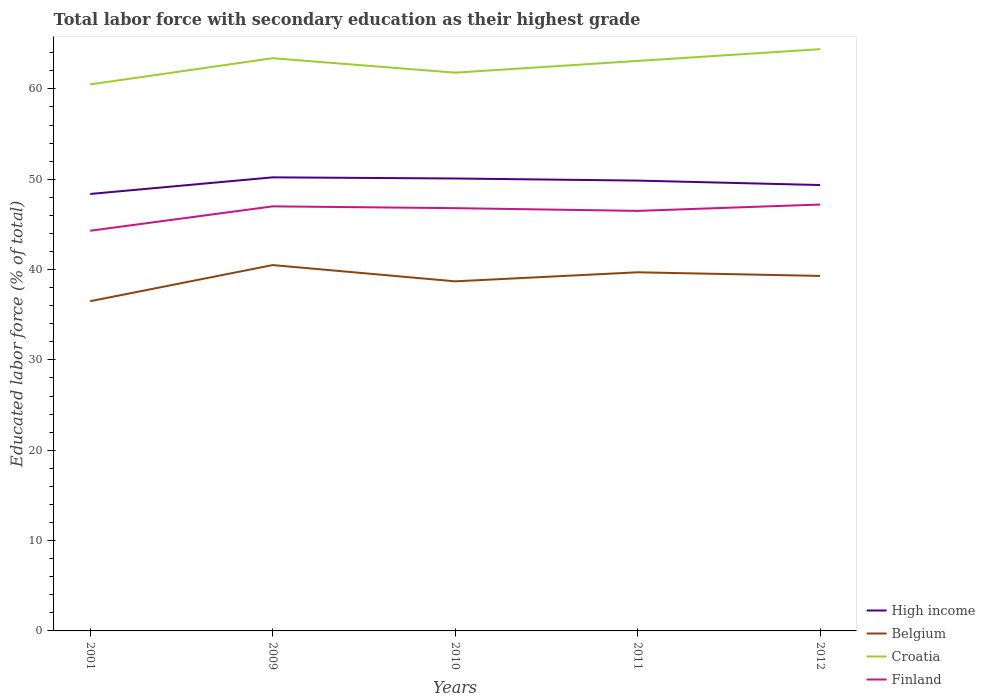Does the line corresponding to Croatia intersect with the line corresponding to High income?
Ensure brevity in your answer.  No. Across all years, what is the maximum percentage of total labor force with primary education in Finland?
Provide a short and direct response. 44.3. In which year was the percentage of total labor force with primary education in High income maximum?
Your answer should be compact. 2001. What is the total percentage of total labor force with primary education in Croatia in the graph?
Provide a succinct answer. 0.3. How many lines are there?
Offer a terse response. 4. How many years are there in the graph?
Keep it short and to the point. 5. What is the difference between two consecutive major ticks on the Y-axis?
Provide a succinct answer. 10. Does the graph contain grids?
Your answer should be very brief. No. How are the legend labels stacked?
Your response must be concise. Vertical. What is the title of the graph?
Provide a short and direct response. Total labor force with secondary education as their highest grade. What is the label or title of the Y-axis?
Make the answer very short. Educated labor force (% of total). What is the Educated labor force (% of total) in High income in 2001?
Offer a terse response. 48.37. What is the Educated labor force (% of total) of Belgium in 2001?
Give a very brief answer. 36.5. What is the Educated labor force (% of total) of Croatia in 2001?
Offer a very short reply. 60.5. What is the Educated labor force (% of total) of Finland in 2001?
Provide a short and direct response. 44.3. What is the Educated labor force (% of total) of High income in 2009?
Provide a succinct answer. 50.21. What is the Educated labor force (% of total) of Belgium in 2009?
Keep it short and to the point. 40.5. What is the Educated labor force (% of total) of Croatia in 2009?
Provide a short and direct response. 63.4. What is the Educated labor force (% of total) of High income in 2010?
Provide a succinct answer. 50.08. What is the Educated labor force (% of total) in Belgium in 2010?
Provide a succinct answer. 38.7. What is the Educated labor force (% of total) of Croatia in 2010?
Provide a short and direct response. 61.8. What is the Educated labor force (% of total) of Finland in 2010?
Give a very brief answer. 46.8. What is the Educated labor force (% of total) in High income in 2011?
Provide a succinct answer. 49.85. What is the Educated labor force (% of total) of Belgium in 2011?
Make the answer very short. 39.7. What is the Educated labor force (% of total) in Croatia in 2011?
Offer a terse response. 63.1. What is the Educated labor force (% of total) in Finland in 2011?
Your response must be concise. 46.5. What is the Educated labor force (% of total) in High income in 2012?
Keep it short and to the point. 49.36. What is the Educated labor force (% of total) of Belgium in 2012?
Ensure brevity in your answer.  39.3. What is the Educated labor force (% of total) in Croatia in 2012?
Your answer should be very brief. 64.4. What is the Educated labor force (% of total) of Finland in 2012?
Make the answer very short. 47.2. Across all years, what is the maximum Educated labor force (% of total) in High income?
Offer a terse response. 50.21. Across all years, what is the maximum Educated labor force (% of total) in Belgium?
Your answer should be very brief. 40.5. Across all years, what is the maximum Educated labor force (% of total) in Croatia?
Ensure brevity in your answer.  64.4. Across all years, what is the maximum Educated labor force (% of total) in Finland?
Your response must be concise. 47.2. Across all years, what is the minimum Educated labor force (% of total) in High income?
Provide a succinct answer. 48.37. Across all years, what is the minimum Educated labor force (% of total) in Belgium?
Your answer should be very brief. 36.5. Across all years, what is the minimum Educated labor force (% of total) of Croatia?
Give a very brief answer. 60.5. Across all years, what is the minimum Educated labor force (% of total) of Finland?
Offer a very short reply. 44.3. What is the total Educated labor force (% of total) in High income in the graph?
Your answer should be very brief. 247.88. What is the total Educated labor force (% of total) in Belgium in the graph?
Provide a short and direct response. 194.7. What is the total Educated labor force (% of total) in Croatia in the graph?
Give a very brief answer. 313.2. What is the total Educated labor force (% of total) in Finland in the graph?
Provide a short and direct response. 231.8. What is the difference between the Educated labor force (% of total) of High income in 2001 and that in 2009?
Offer a terse response. -1.84. What is the difference between the Educated labor force (% of total) in Belgium in 2001 and that in 2009?
Give a very brief answer. -4. What is the difference between the Educated labor force (% of total) in High income in 2001 and that in 2010?
Provide a succinct answer. -1.71. What is the difference between the Educated labor force (% of total) in Belgium in 2001 and that in 2010?
Your answer should be compact. -2.2. What is the difference between the Educated labor force (% of total) of Finland in 2001 and that in 2010?
Your answer should be very brief. -2.5. What is the difference between the Educated labor force (% of total) in High income in 2001 and that in 2011?
Provide a short and direct response. -1.48. What is the difference between the Educated labor force (% of total) of Belgium in 2001 and that in 2011?
Offer a terse response. -3.2. What is the difference between the Educated labor force (% of total) of High income in 2001 and that in 2012?
Ensure brevity in your answer.  -0.99. What is the difference between the Educated labor force (% of total) of Belgium in 2001 and that in 2012?
Your response must be concise. -2.8. What is the difference between the Educated labor force (% of total) of High income in 2009 and that in 2010?
Offer a very short reply. 0.13. What is the difference between the Educated labor force (% of total) in Belgium in 2009 and that in 2010?
Provide a succinct answer. 1.8. What is the difference between the Educated labor force (% of total) in High income in 2009 and that in 2011?
Provide a succinct answer. 0.36. What is the difference between the Educated labor force (% of total) of Croatia in 2009 and that in 2011?
Keep it short and to the point. 0.3. What is the difference between the Educated labor force (% of total) of High income in 2009 and that in 2012?
Make the answer very short. 0.85. What is the difference between the Educated labor force (% of total) in Belgium in 2009 and that in 2012?
Your answer should be compact. 1.2. What is the difference between the Educated labor force (% of total) of Croatia in 2009 and that in 2012?
Ensure brevity in your answer.  -1. What is the difference between the Educated labor force (% of total) in Finland in 2009 and that in 2012?
Offer a terse response. -0.2. What is the difference between the Educated labor force (% of total) in High income in 2010 and that in 2011?
Keep it short and to the point. 0.23. What is the difference between the Educated labor force (% of total) in Belgium in 2010 and that in 2011?
Ensure brevity in your answer.  -1. What is the difference between the Educated labor force (% of total) in High income in 2010 and that in 2012?
Provide a short and direct response. 0.72. What is the difference between the Educated labor force (% of total) of Belgium in 2010 and that in 2012?
Offer a terse response. -0.6. What is the difference between the Educated labor force (% of total) of Croatia in 2010 and that in 2012?
Offer a terse response. -2.6. What is the difference between the Educated labor force (% of total) in Finland in 2010 and that in 2012?
Give a very brief answer. -0.4. What is the difference between the Educated labor force (% of total) in High income in 2011 and that in 2012?
Your response must be concise. 0.49. What is the difference between the Educated labor force (% of total) in Belgium in 2011 and that in 2012?
Your answer should be very brief. 0.4. What is the difference between the Educated labor force (% of total) in Croatia in 2011 and that in 2012?
Offer a terse response. -1.3. What is the difference between the Educated labor force (% of total) in High income in 2001 and the Educated labor force (% of total) in Belgium in 2009?
Your answer should be compact. 7.87. What is the difference between the Educated labor force (% of total) in High income in 2001 and the Educated labor force (% of total) in Croatia in 2009?
Give a very brief answer. -15.03. What is the difference between the Educated labor force (% of total) in High income in 2001 and the Educated labor force (% of total) in Finland in 2009?
Offer a terse response. 1.37. What is the difference between the Educated labor force (% of total) of Belgium in 2001 and the Educated labor force (% of total) of Croatia in 2009?
Offer a very short reply. -26.9. What is the difference between the Educated labor force (% of total) in Belgium in 2001 and the Educated labor force (% of total) in Finland in 2009?
Provide a short and direct response. -10.5. What is the difference between the Educated labor force (% of total) of High income in 2001 and the Educated labor force (% of total) of Belgium in 2010?
Keep it short and to the point. 9.67. What is the difference between the Educated labor force (% of total) of High income in 2001 and the Educated labor force (% of total) of Croatia in 2010?
Offer a terse response. -13.43. What is the difference between the Educated labor force (% of total) of High income in 2001 and the Educated labor force (% of total) of Finland in 2010?
Offer a very short reply. 1.57. What is the difference between the Educated labor force (% of total) of Belgium in 2001 and the Educated labor force (% of total) of Croatia in 2010?
Provide a succinct answer. -25.3. What is the difference between the Educated labor force (% of total) in High income in 2001 and the Educated labor force (% of total) in Belgium in 2011?
Ensure brevity in your answer.  8.67. What is the difference between the Educated labor force (% of total) of High income in 2001 and the Educated labor force (% of total) of Croatia in 2011?
Your response must be concise. -14.73. What is the difference between the Educated labor force (% of total) in High income in 2001 and the Educated labor force (% of total) in Finland in 2011?
Give a very brief answer. 1.87. What is the difference between the Educated labor force (% of total) in Belgium in 2001 and the Educated labor force (% of total) in Croatia in 2011?
Provide a succinct answer. -26.6. What is the difference between the Educated labor force (% of total) in Croatia in 2001 and the Educated labor force (% of total) in Finland in 2011?
Your response must be concise. 14. What is the difference between the Educated labor force (% of total) in High income in 2001 and the Educated labor force (% of total) in Belgium in 2012?
Keep it short and to the point. 9.07. What is the difference between the Educated labor force (% of total) of High income in 2001 and the Educated labor force (% of total) of Croatia in 2012?
Your response must be concise. -16.03. What is the difference between the Educated labor force (% of total) in High income in 2001 and the Educated labor force (% of total) in Finland in 2012?
Your response must be concise. 1.17. What is the difference between the Educated labor force (% of total) in Belgium in 2001 and the Educated labor force (% of total) in Croatia in 2012?
Your response must be concise. -27.9. What is the difference between the Educated labor force (% of total) in Belgium in 2001 and the Educated labor force (% of total) in Finland in 2012?
Your answer should be very brief. -10.7. What is the difference between the Educated labor force (% of total) of Croatia in 2001 and the Educated labor force (% of total) of Finland in 2012?
Your answer should be compact. 13.3. What is the difference between the Educated labor force (% of total) of High income in 2009 and the Educated labor force (% of total) of Belgium in 2010?
Ensure brevity in your answer.  11.51. What is the difference between the Educated labor force (% of total) in High income in 2009 and the Educated labor force (% of total) in Croatia in 2010?
Offer a terse response. -11.59. What is the difference between the Educated labor force (% of total) in High income in 2009 and the Educated labor force (% of total) in Finland in 2010?
Provide a short and direct response. 3.41. What is the difference between the Educated labor force (% of total) of Belgium in 2009 and the Educated labor force (% of total) of Croatia in 2010?
Your answer should be compact. -21.3. What is the difference between the Educated labor force (% of total) in Croatia in 2009 and the Educated labor force (% of total) in Finland in 2010?
Your answer should be very brief. 16.6. What is the difference between the Educated labor force (% of total) in High income in 2009 and the Educated labor force (% of total) in Belgium in 2011?
Give a very brief answer. 10.51. What is the difference between the Educated labor force (% of total) in High income in 2009 and the Educated labor force (% of total) in Croatia in 2011?
Make the answer very short. -12.89. What is the difference between the Educated labor force (% of total) in High income in 2009 and the Educated labor force (% of total) in Finland in 2011?
Your response must be concise. 3.71. What is the difference between the Educated labor force (% of total) of Belgium in 2009 and the Educated labor force (% of total) of Croatia in 2011?
Give a very brief answer. -22.6. What is the difference between the Educated labor force (% of total) of High income in 2009 and the Educated labor force (% of total) of Belgium in 2012?
Offer a very short reply. 10.91. What is the difference between the Educated labor force (% of total) in High income in 2009 and the Educated labor force (% of total) in Croatia in 2012?
Your answer should be very brief. -14.19. What is the difference between the Educated labor force (% of total) in High income in 2009 and the Educated labor force (% of total) in Finland in 2012?
Provide a short and direct response. 3.01. What is the difference between the Educated labor force (% of total) of Belgium in 2009 and the Educated labor force (% of total) of Croatia in 2012?
Your answer should be compact. -23.9. What is the difference between the Educated labor force (% of total) in Croatia in 2009 and the Educated labor force (% of total) in Finland in 2012?
Offer a terse response. 16.2. What is the difference between the Educated labor force (% of total) in High income in 2010 and the Educated labor force (% of total) in Belgium in 2011?
Keep it short and to the point. 10.38. What is the difference between the Educated labor force (% of total) in High income in 2010 and the Educated labor force (% of total) in Croatia in 2011?
Offer a very short reply. -13.02. What is the difference between the Educated labor force (% of total) in High income in 2010 and the Educated labor force (% of total) in Finland in 2011?
Give a very brief answer. 3.58. What is the difference between the Educated labor force (% of total) of Belgium in 2010 and the Educated labor force (% of total) of Croatia in 2011?
Your response must be concise. -24.4. What is the difference between the Educated labor force (% of total) of High income in 2010 and the Educated labor force (% of total) of Belgium in 2012?
Provide a succinct answer. 10.78. What is the difference between the Educated labor force (% of total) in High income in 2010 and the Educated labor force (% of total) in Croatia in 2012?
Offer a very short reply. -14.32. What is the difference between the Educated labor force (% of total) of High income in 2010 and the Educated labor force (% of total) of Finland in 2012?
Your response must be concise. 2.88. What is the difference between the Educated labor force (% of total) in Belgium in 2010 and the Educated labor force (% of total) in Croatia in 2012?
Offer a very short reply. -25.7. What is the difference between the Educated labor force (% of total) in Belgium in 2010 and the Educated labor force (% of total) in Finland in 2012?
Ensure brevity in your answer.  -8.5. What is the difference between the Educated labor force (% of total) in Croatia in 2010 and the Educated labor force (% of total) in Finland in 2012?
Provide a short and direct response. 14.6. What is the difference between the Educated labor force (% of total) in High income in 2011 and the Educated labor force (% of total) in Belgium in 2012?
Your answer should be compact. 10.55. What is the difference between the Educated labor force (% of total) in High income in 2011 and the Educated labor force (% of total) in Croatia in 2012?
Ensure brevity in your answer.  -14.55. What is the difference between the Educated labor force (% of total) in High income in 2011 and the Educated labor force (% of total) in Finland in 2012?
Provide a short and direct response. 2.65. What is the difference between the Educated labor force (% of total) in Belgium in 2011 and the Educated labor force (% of total) in Croatia in 2012?
Your response must be concise. -24.7. What is the average Educated labor force (% of total) of High income per year?
Your answer should be very brief. 49.58. What is the average Educated labor force (% of total) in Belgium per year?
Provide a short and direct response. 38.94. What is the average Educated labor force (% of total) of Croatia per year?
Offer a very short reply. 62.64. What is the average Educated labor force (% of total) in Finland per year?
Your answer should be very brief. 46.36. In the year 2001, what is the difference between the Educated labor force (% of total) of High income and Educated labor force (% of total) of Belgium?
Make the answer very short. 11.87. In the year 2001, what is the difference between the Educated labor force (% of total) of High income and Educated labor force (% of total) of Croatia?
Ensure brevity in your answer.  -12.13. In the year 2001, what is the difference between the Educated labor force (% of total) of High income and Educated labor force (% of total) of Finland?
Make the answer very short. 4.07. In the year 2001, what is the difference between the Educated labor force (% of total) of Belgium and Educated labor force (% of total) of Croatia?
Your response must be concise. -24. In the year 2001, what is the difference between the Educated labor force (% of total) of Belgium and Educated labor force (% of total) of Finland?
Your answer should be compact. -7.8. In the year 2009, what is the difference between the Educated labor force (% of total) in High income and Educated labor force (% of total) in Belgium?
Provide a short and direct response. 9.71. In the year 2009, what is the difference between the Educated labor force (% of total) in High income and Educated labor force (% of total) in Croatia?
Give a very brief answer. -13.19. In the year 2009, what is the difference between the Educated labor force (% of total) in High income and Educated labor force (% of total) in Finland?
Your answer should be very brief. 3.21. In the year 2009, what is the difference between the Educated labor force (% of total) of Belgium and Educated labor force (% of total) of Croatia?
Make the answer very short. -22.9. In the year 2009, what is the difference between the Educated labor force (% of total) of Belgium and Educated labor force (% of total) of Finland?
Keep it short and to the point. -6.5. In the year 2009, what is the difference between the Educated labor force (% of total) in Croatia and Educated labor force (% of total) in Finland?
Offer a terse response. 16.4. In the year 2010, what is the difference between the Educated labor force (% of total) in High income and Educated labor force (% of total) in Belgium?
Offer a very short reply. 11.38. In the year 2010, what is the difference between the Educated labor force (% of total) in High income and Educated labor force (% of total) in Croatia?
Offer a very short reply. -11.72. In the year 2010, what is the difference between the Educated labor force (% of total) of High income and Educated labor force (% of total) of Finland?
Your answer should be very brief. 3.28. In the year 2010, what is the difference between the Educated labor force (% of total) in Belgium and Educated labor force (% of total) in Croatia?
Your answer should be compact. -23.1. In the year 2010, what is the difference between the Educated labor force (% of total) in Croatia and Educated labor force (% of total) in Finland?
Provide a short and direct response. 15. In the year 2011, what is the difference between the Educated labor force (% of total) in High income and Educated labor force (% of total) in Belgium?
Give a very brief answer. 10.15. In the year 2011, what is the difference between the Educated labor force (% of total) in High income and Educated labor force (% of total) in Croatia?
Your answer should be very brief. -13.25. In the year 2011, what is the difference between the Educated labor force (% of total) of High income and Educated labor force (% of total) of Finland?
Make the answer very short. 3.35. In the year 2011, what is the difference between the Educated labor force (% of total) of Belgium and Educated labor force (% of total) of Croatia?
Your answer should be compact. -23.4. In the year 2011, what is the difference between the Educated labor force (% of total) of Belgium and Educated labor force (% of total) of Finland?
Offer a very short reply. -6.8. In the year 2012, what is the difference between the Educated labor force (% of total) in High income and Educated labor force (% of total) in Belgium?
Your answer should be compact. 10.06. In the year 2012, what is the difference between the Educated labor force (% of total) of High income and Educated labor force (% of total) of Croatia?
Ensure brevity in your answer.  -15.04. In the year 2012, what is the difference between the Educated labor force (% of total) in High income and Educated labor force (% of total) in Finland?
Give a very brief answer. 2.16. In the year 2012, what is the difference between the Educated labor force (% of total) of Belgium and Educated labor force (% of total) of Croatia?
Offer a terse response. -25.1. In the year 2012, what is the difference between the Educated labor force (% of total) of Belgium and Educated labor force (% of total) of Finland?
Keep it short and to the point. -7.9. What is the ratio of the Educated labor force (% of total) in High income in 2001 to that in 2009?
Make the answer very short. 0.96. What is the ratio of the Educated labor force (% of total) of Belgium in 2001 to that in 2009?
Ensure brevity in your answer.  0.9. What is the ratio of the Educated labor force (% of total) of Croatia in 2001 to that in 2009?
Offer a terse response. 0.95. What is the ratio of the Educated labor force (% of total) of Finland in 2001 to that in 2009?
Provide a short and direct response. 0.94. What is the ratio of the Educated labor force (% of total) in High income in 2001 to that in 2010?
Ensure brevity in your answer.  0.97. What is the ratio of the Educated labor force (% of total) of Belgium in 2001 to that in 2010?
Make the answer very short. 0.94. What is the ratio of the Educated labor force (% of total) in Croatia in 2001 to that in 2010?
Offer a very short reply. 0.98. What is the ratio of the Educated labor force (% of total) in Finland in 2001 to that in 2010?
Offer a terse response. 0.95. What is the ratio of the Educated labor force (% of total) in High income in 2001 to that in 2011?
Your answer should be very brief. 0.97. What is the ratio of the Educated labor force (% of total) in Belgium in 2001 to that in 2011?
Provide a short and direct response. 0.92. What is the ratio of the Educated labor force (% of total) of Croatia in 2001 to that in 2011?
Provide a succinct answer. 0.96. What is the ratio of the Educated labor force (% of total) of Finland in 2001 to that in 2011?
Your response must be concise. 0.95. What is the ratio of the Educated labor force (% of total) of High income in 2001 to that in 2012?
Ensure brevity in your answer.  0.98. What is the ratio of the Educated labor force (% of total) of Belgium in 2001 to that in 2012?
Give a very brief answer. 0.93. What is the ratio of the Educated labor force (% of total) of Croatia in 2001 to that in 2012?
Make the answer very short. 0.94. What is the ratio of the Educated labor force (% of total) of Finland in 2001 to that in 2012?
Provide a succinct answer. 0.94. What is the ratio of the Educated labor force (% of total) in Belgium in 2009 to that in 2010?
Provide a short and direct response. 1.05. What is the ratio of the Educated labor force (% of total) in Croatia in 2009 to that in 2010?
Offer a very short reply. 1.03. What is the ratio of the Educated labor force (% of total) in Finland in 2009 to that in 2010?
Make the answer very short. 1. What is the ratio of the Educated labor force (% of total) in High income in 2009 to that in 2011?
Offer a very short reply. 1.01. What is the ratio of the Educated labor force (% of total) of Belgium in 2009 to that in 2011?
Give a very brief answer. 1.02. What is the ratio of the Educated labor force (% of total) in Finland in 2009 to that in 2011?
Offer a terse response. 1.01. What is the ratio of the Educated labor force (% of total) of High income in 2009 to that in 2012?
Your answer should be compact. 1.02. What is the ratio of the Educated labor force (% of total) of Belgium in 2009 to that in 2012?
Keep it short and to the point. 1.03. What is the ratio of the Educated labor force (% of total) in Croatia in 2009 to that in 2012?
Provide a succinct answer. 0.98. What is the ratio of the Educated labor force (% of total) of High income in 2010 to that in 2011?
Keep it short and to the point. 1. What is the ratio of the Educated labor force (% of total) of Belgium in 2010 to that in 2011?
Provide a short and direct response. 0.97. What is the ratio of the Educated labor force (% of total) of Croatia in 2010 to that in 2011?
Make the answer very short. 0.98. What is the ratio of the Educated labor force (% of total) in High income in 2010 to that in 2012?
Offer a very short reply. 1.01. What is the ratio of the Educated labor force (% of total) in Belgium in 2010 to that in 2012?
Give a very brief answer. 0.98. What is the ratio of the Educated labor force (% of total) of Croatia in 2010 to that in 2012?
Your response must be concise. 0.96. What is the ratio of the Educated labor force (% of total) of Belgium in 2011 to that in 2012?
Your answer should be compact. 1.01. What is the ratio of the Educated labor force (% of total) in Croatia in 2011 to that in 2012?
Your response must be concise. 0.98. What is the ratio of the Educated labor force (% of total) in Finland in 2011 to that in 2012?
Make the answer very short. 0.99. What is the difference between the highest and the second highest Educated labor force (% of total) of High income?
Provide a succinct answer. 0.13. What is the difference between the highest and the second highest Educated labor force (% of total) in Belgium?
Give a very brief answer. 0.8. What is the difference between the highest and the second highest Educated labor force (% of total) of Finland?
Make the answer very short. 0.2. What is the difference between the highest and the lowest Educated labor force (% of total) of High income?
Offer a very short reply. 1.84. What is the difference between the highest and the lowest Educated labor force (% of total) in Croatia?
Your response must be concise. 3.9. What is the difference between the highest and the lowest Educated labor force (% of total) in Finland?
Give a very brief answer. 2.9. 